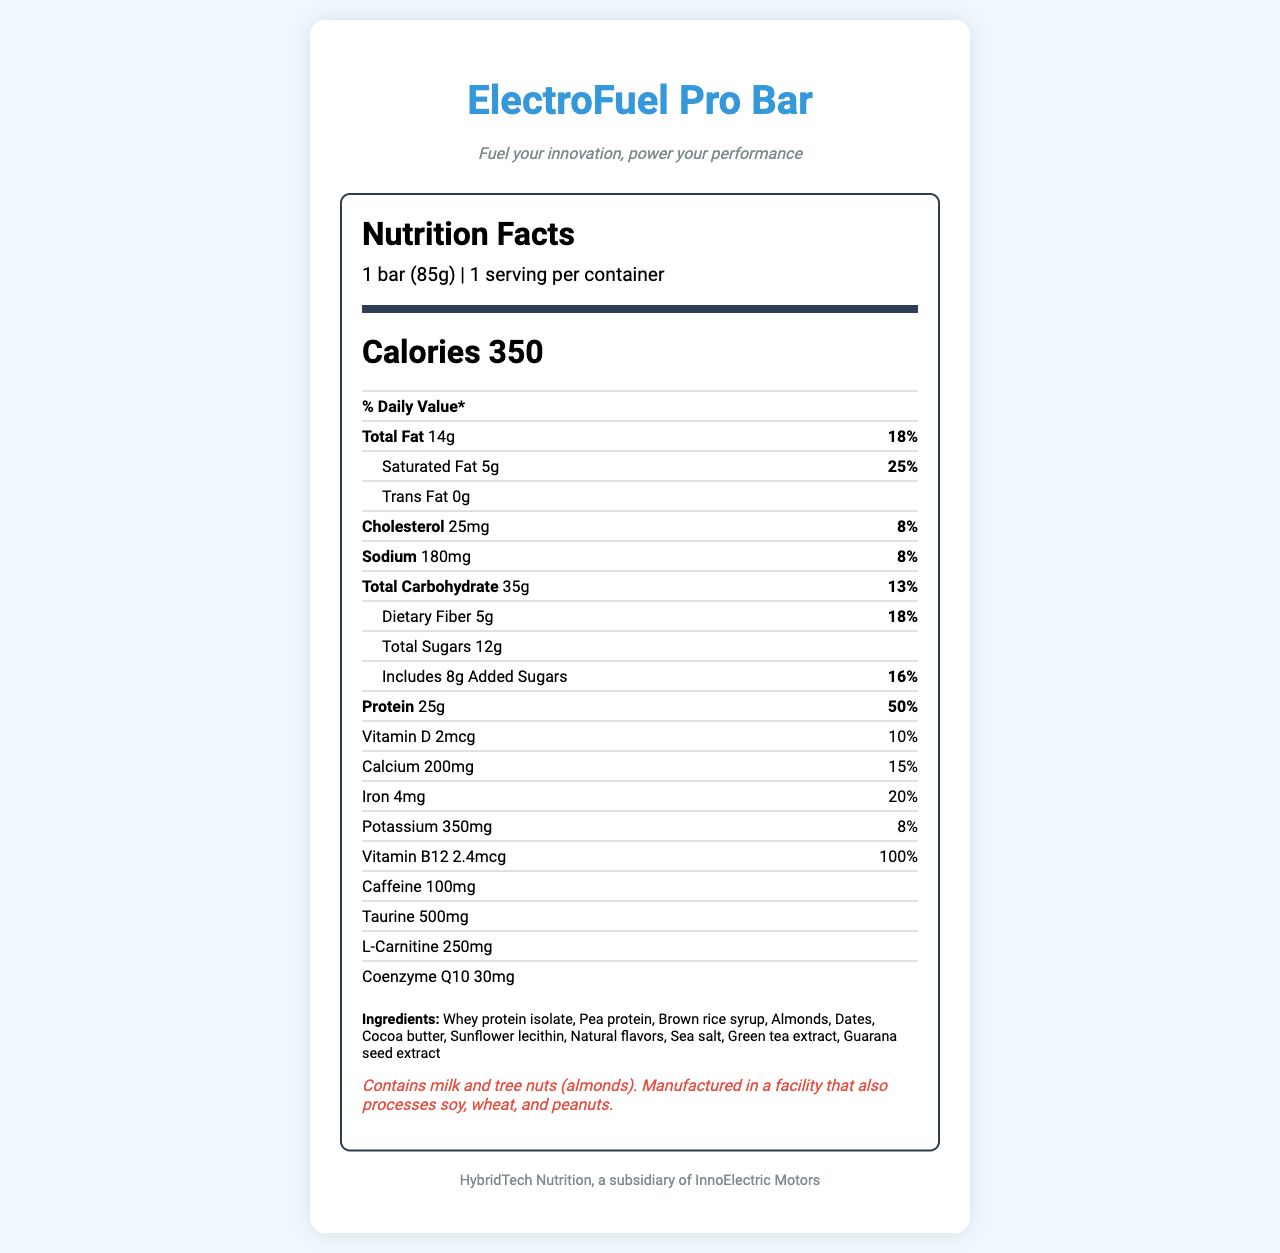What is the serving size of the ElectroFuel Pro Bar? The serving size is listed at the top of the nutrition label as "1 bar (85g)".
Answer: 1 bar (85g) How many calories are in one serving of ElectroFuel Pro Bar? The calories per serving are listed prominently as "Calories 350".
Answer: 350 What percentage of the daily value of protein does the ElectroFuel Pro Bar provide? This information is found in the protein section which states "Protein 25g 50%".
Answer: 50% Does the ElectroFuel Pro Bar contain trans fat? Yes or No? The trans fat content is listed as "0g", which means there is no trans fat in the bar.
Answer: No How much sugar is in the ElectroFuel Pro Bar? The total sugars content is listed as "Total Sugars 12g".
Answer: 12g total sugars Which of the following ingredients are included in the ElectroFuel Pro Bar? A. Pea protein B. Corn syrup C. Soy lecithin D. Peanut butter The ingredients list includes "Pea protein" but does not include "Corn syrup", "Soy lecithin", or "Peanut butter".
Answer: A What is the amount of dietary fiber in one bar? The dietary fiber content is listed as "Dietary Fiber 5g".
Answer: 5g What is the tagline of the ElectroFuel Pro Bar? The tagline is listed right under the product name at the top of the label.
Answer: Fuel your innovation, power your performance What is the name of the manufacturer of the ElectroFuel Pro Bar? A. HybridTech Nutrition B. InnoElectric Motors C. Both A and B D. Neither The manufacturer is listed as "HybridTech Nutrition, a subsidiary of InnoElectric Motors".
Answer: C What is the main message of the document? The document is centered around the nutritional value and benefits of the ElectroFuel Pro Bar, specifically marketed toward hybrid vehicle engineers to support long hours of work.
Answer: ElectroFuel Pro Bar is a high-energy protein bar designed to keep hybrid vehicle engineers working long hours at peak performance, providing essential nutrients, energy, and mental clarity. What is the daily value percentage of calcium in the ElectroFuel Pro Bar? The daily value percentage for calcium is listed as "15%".
Answer: 15% Can the ElectroFuel Pro Bar be consumed by someone with a peanut allergy? The allergen information states that the bar contains milk and tree nuts and that it is manufactured in a facility that processes peanuts, but it does not explicitly state that peanuts are present in the bar.
Answer: Not enough information Is the ElectroFuel Pro Bar suitable for someone needing to avoid high cholesterol foods? The bar contains 25mg of cholesterol, which contributes 8% of the daily value, potentially making it unsuitable for someone needing to avoid high cholesterol foods.
Answer: No 